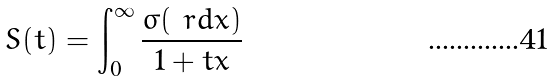<formula> <loc_0><loc_0><loc_500><loc_500>S ( t ) = \int _ { 0 } ^ { \infty } \frac { \sigma ( \ r d x ) } { 1 + t x }</formula> 